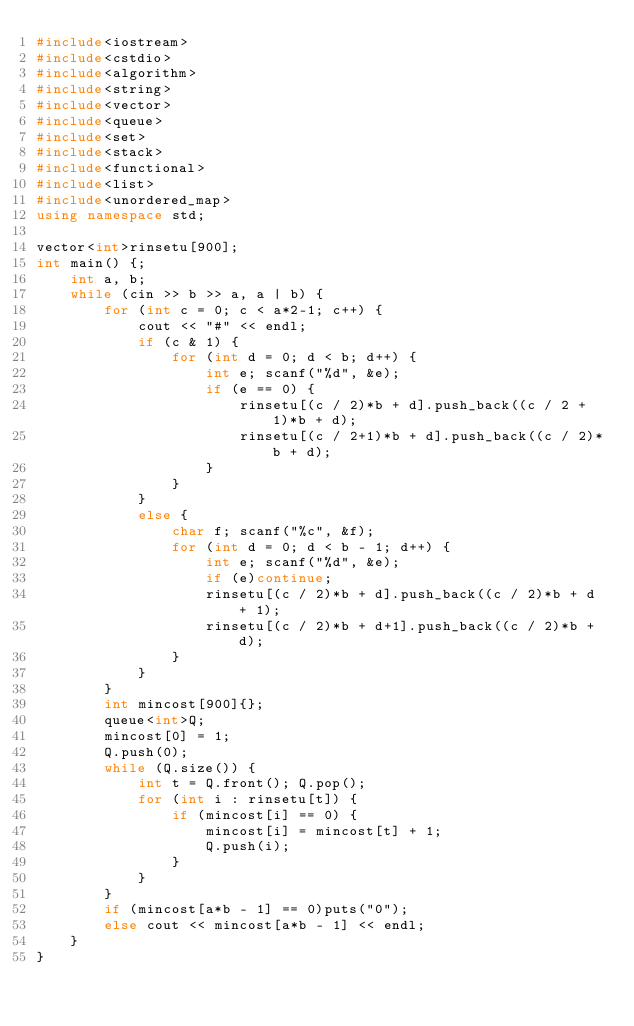<code> <loc_0><loc_0><loc_500><loc_500><_C++_>#include<iostream>
#include<cstdio>
#include<algorithm>
#include<string>
#include<vector>
#include<queue>
#include<set>
#include<stack>
#include<functional>
#include<list>
#include<unordered_map>
using namespace std;

vector<int>rinsetu[900];
int main() {;
	int a, b;
	while (cin >> b >> a, a | b) {
		for (int c = 0; c < a*2-1; c++) {
			cout << "#" << endl;
			if (c & 1) {
				for (int d = 0; d < b; d++) {
					int e; scanf("%d", &e);
					if (e == 0) {
						rinsetu[(c / 2)*b + d].push_back((c / 2 + 1)*b + d);
						rinsetu[(c / 2+1)*b + d].push_back((c / 2)*b + d);
					}
				}
			}
			else {
				char f; scanf("%c", &f);
				for (int d = 0; d < b - 1; d++) {
					int e; scanf("%d", &e);
					if (e)continue;
					rinsetu[(c / 2)*b + d].push_back((c / 2)*b + d + 1);
					rinsetu[(c / 2)*b + d+1].push_back((c / 2)*b + d);
				}
			}
		}
		int mincost[900]{};
		queue<int>Q;
		mincost[0] = 1;
		Q.push(0);
		while (Q.size()) {
			int t = Q.front(); Q.pop();
			for (int i : rinsetu[t]) {
				if (mincost[i] == 0) {
					mincost[i] = mincost[t] + 1;
					Q.push(i);
				}
			}
		}
		if (mincost[a*b - 1] == 0)puts("0");
		else cout << mincost[a*b - 1] << endl;
	}
}</code> 